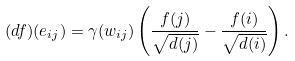Convert formula to latex. <formula><loc_0><loc_0><loc_500><loc_500>( d f ) ( e _ { i j } ) = \gamma ( w _ { i j } ) \left ( \frac { f ( j ) } { \sqrt { d ( j ) } } - \frac { f ( i ) } { \sqrt { d ( i ) } } \right ) .</formula> 